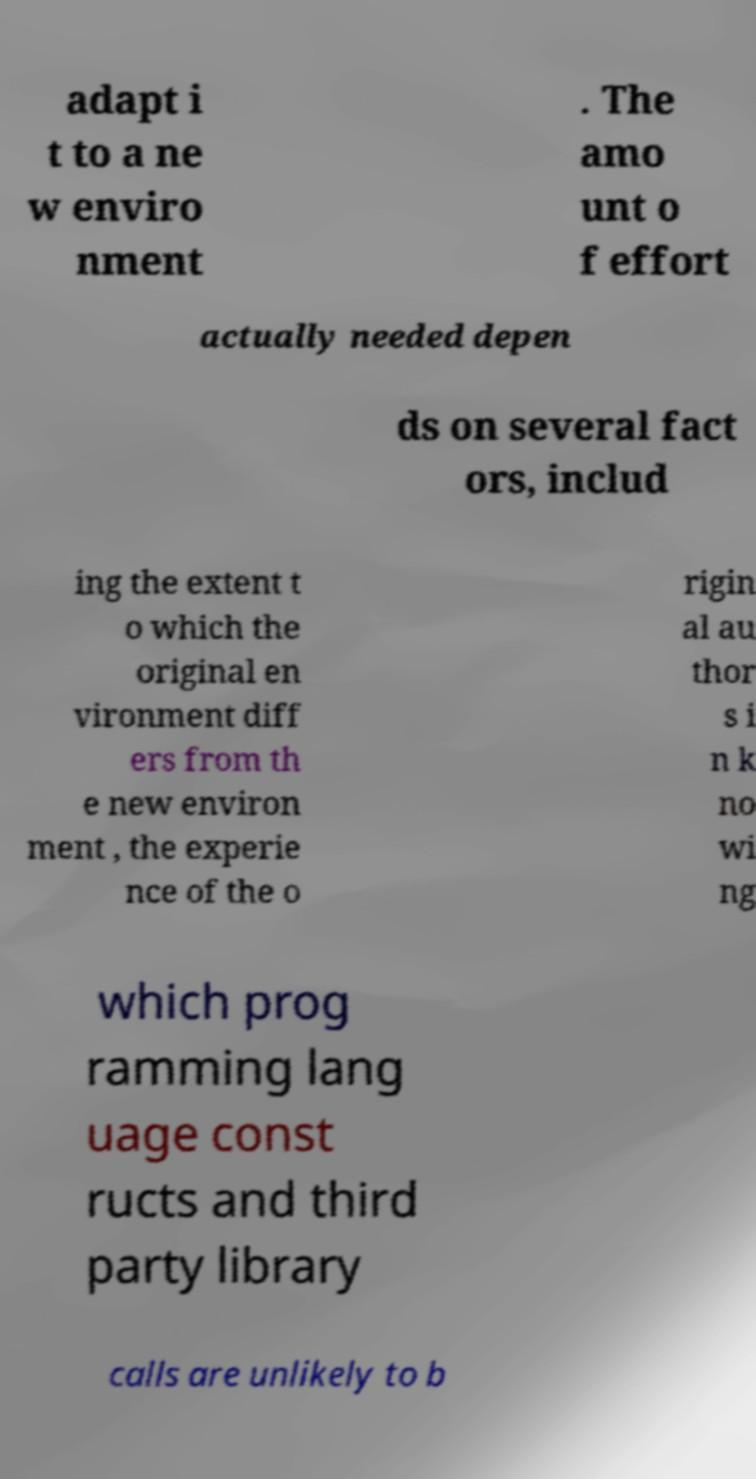Can you accurately transcribe the text from the provided image for me? adapt i t to a ne w enviro nment . The amo unt o f effort actually needed depen ds on several fact ors, includ ing the extent t o which the original en vironment diff ers from th e new environ ment , the experie nce of the o rigin al au thor s i n k no wi ng which prog ramming lang uage const ructs and third party library calls are unlikely to b 